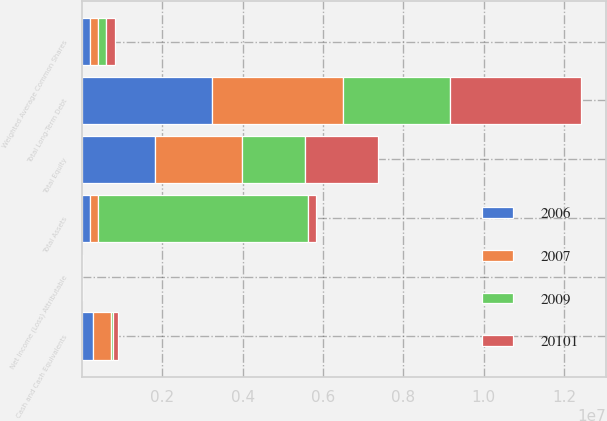Convert chart. <chart><loc_0><loc_0><loc_500><loc_500><stacked_bar_chart><ecel><fcel>Net Income (Loss) Attributable<fcel>Weighted Average Common Shares<fcel>Cash and Cash Equivalents<fcel>Total Assets<fcel>Total Long-Term Debt<fcel>Total Equity<nl><fcel>2009<fcel>0.64<fcel>200463<fcel>45369<fcel>5.20952e+06<fcel>2.66882e+06<fcel>1.57079e+06<nl><fcel>20101<fcel>0.76<fcel>202062<fcel>125607<fcel>202062<fcel>3.26629e+06<fcel>1.81677e+06<nl><fcel>2006<fcel>0.4<fcel>203290<fcel>278370<fcel>202062<fcel>3.24322e+06<fcel>1.81855e+06<nl><fcel>2007<fcel>1.08<fcel>204271<fcel>446656<fcel>202062<fcel>3.25178e+06<fcel>2.15747e+06<nl></chart> 